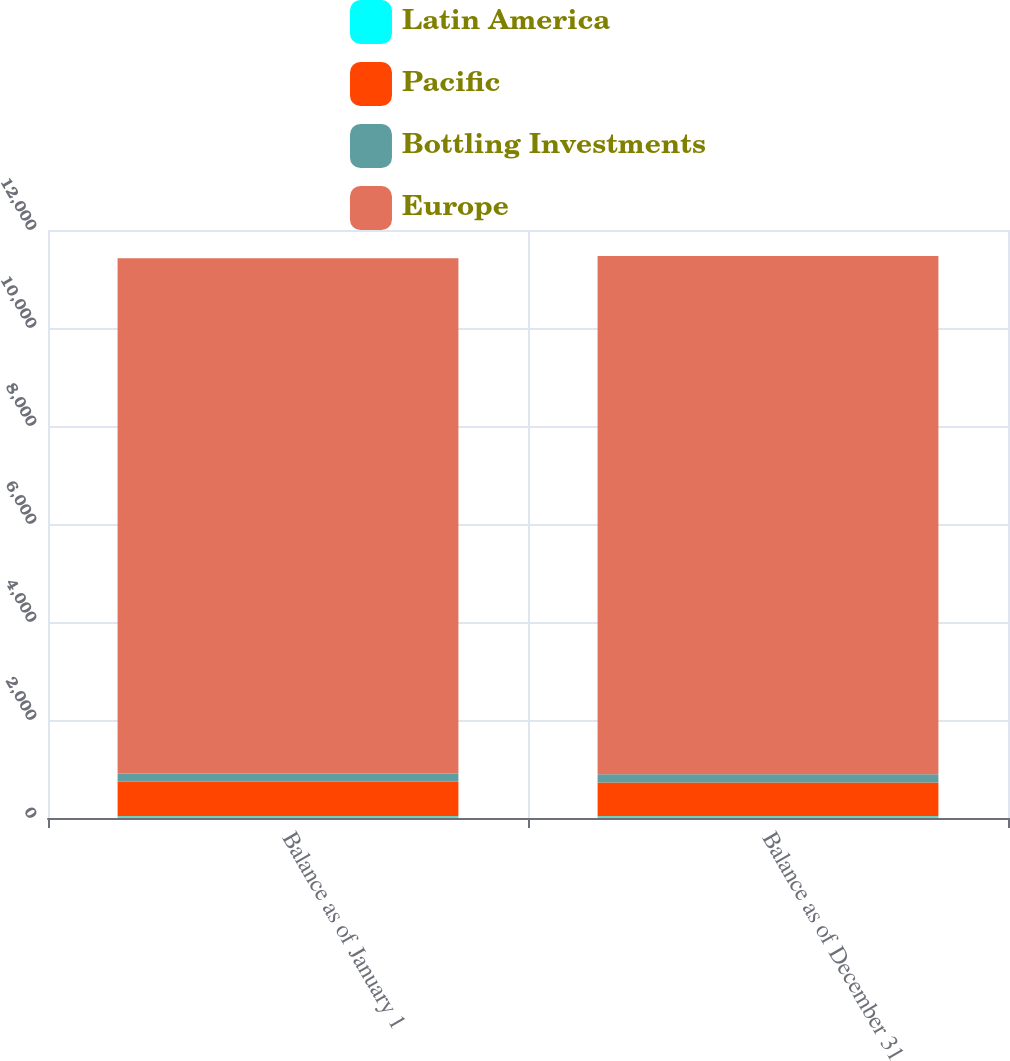<chart> <loc_0><loc_0><loc_500><loc_500><stacked_bar_chart><ecel><fcel>Balance as of January 1<fcel>Balance as of December 31<nl><fcel>Latin America<fcel>35<fcel>34<nl><fcel>Pacific<fcel>710<fcel>691<nl><fcel>Bottling Investments<fcel>163<fcel>168<nl><fcel>Europe<fcel>10515<fcel>10577<nl></chart> 